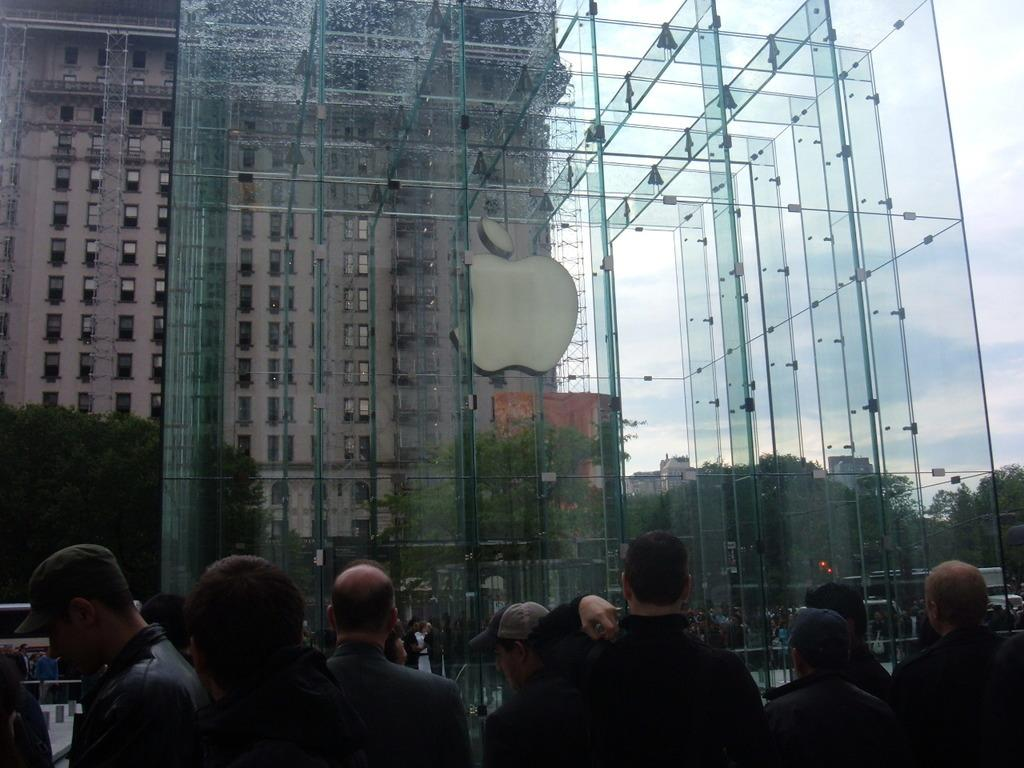What type of structures can be seen in the image? There are buildings in the image. What objects are visible on a surface in the image? There are glasses in the image. What type of vegetation is present in the image? There are trees in the image. What are the people in the image doing? There are people standing on the road in the image. What is visible in the background of the image? The sky is visible in the image, and clouds are present in the sky. What type of advertisement can be seen on the ladybug in the image? There is no ladybug present in the image, and therefore no advertisement can be seen on it. What type of test is being conducted on the people standing on the road in the image? There is no test being conducted on the people standing on the road in the image. 